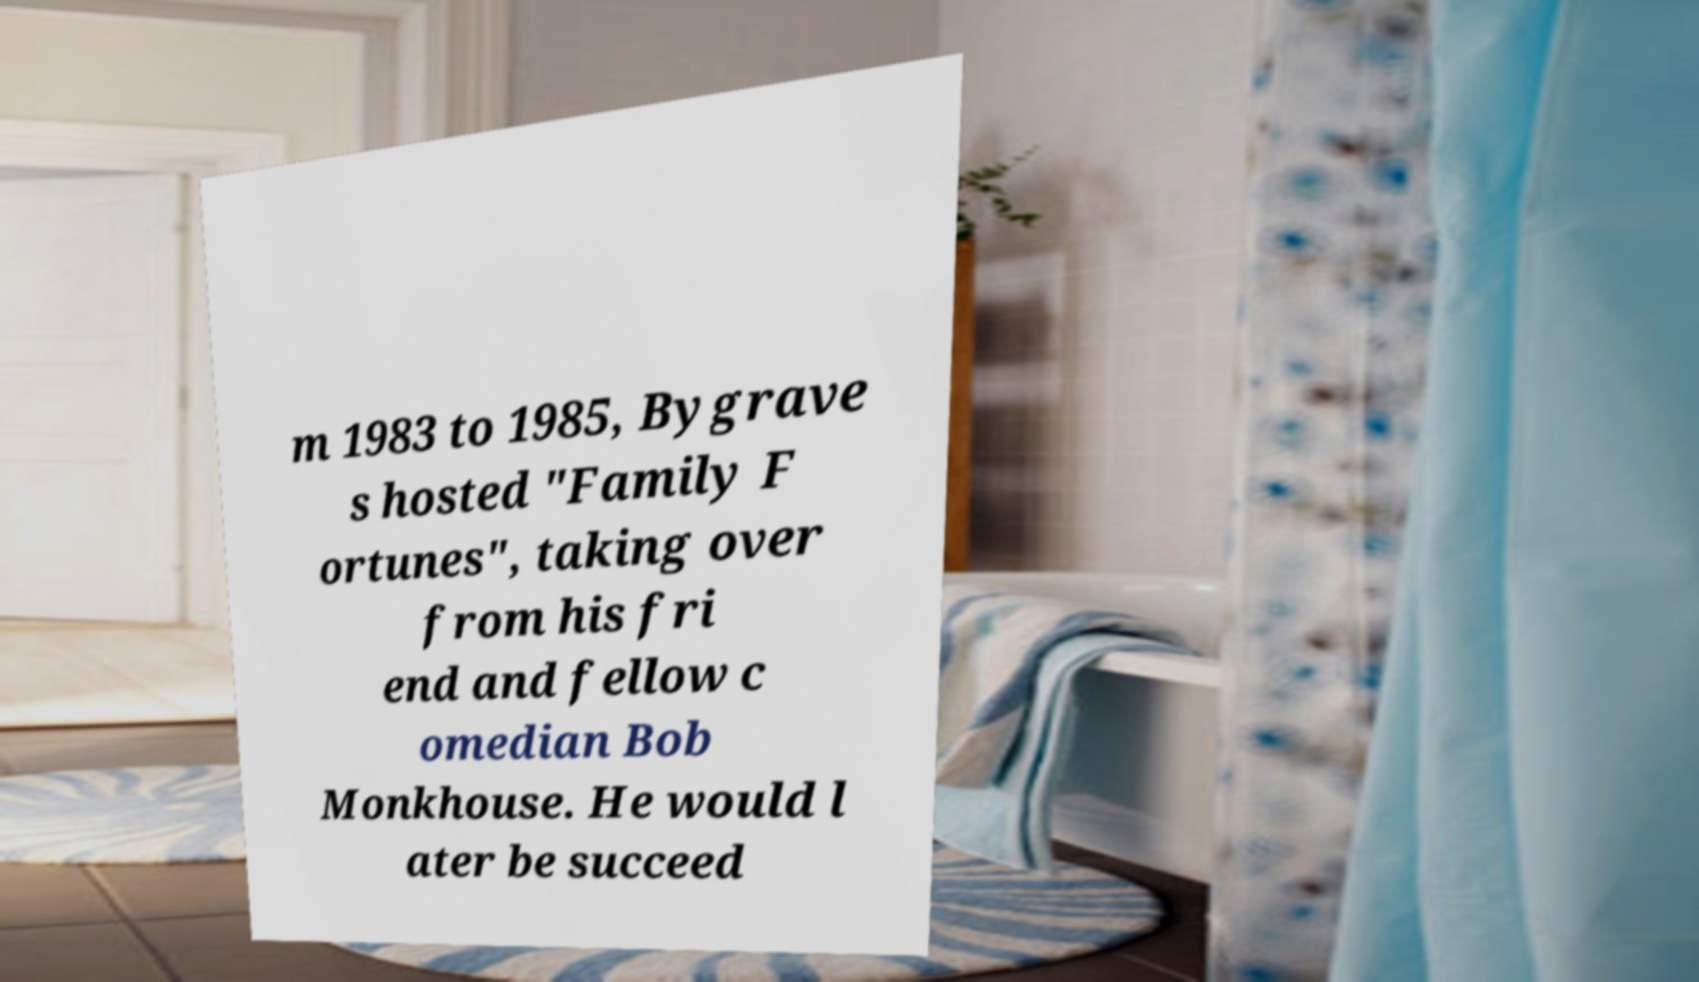Please read and relay the text visible in this image. What does it say? m 1983 to 1985, Bygrave s hosted "Family F ortunes", taking over from his fri end and fellow c omedian Bob Monkhouse. He would l ater be succeed 